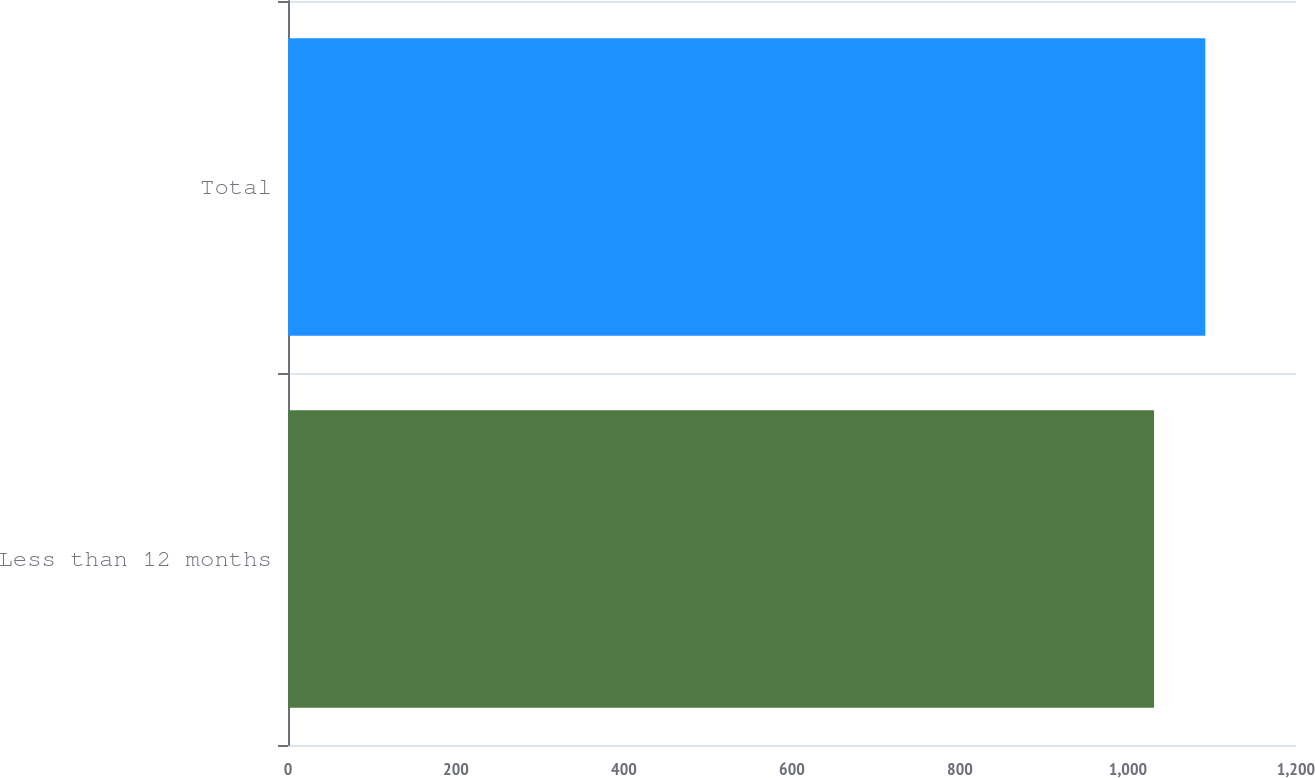Convert chart. <chart><loc_0><loc_0><loc_500><loc_500><bar_chart><fcel>Less than 12 months<fcel>Total<nl><fcel>1031<fcel>1092<nl></chart> 